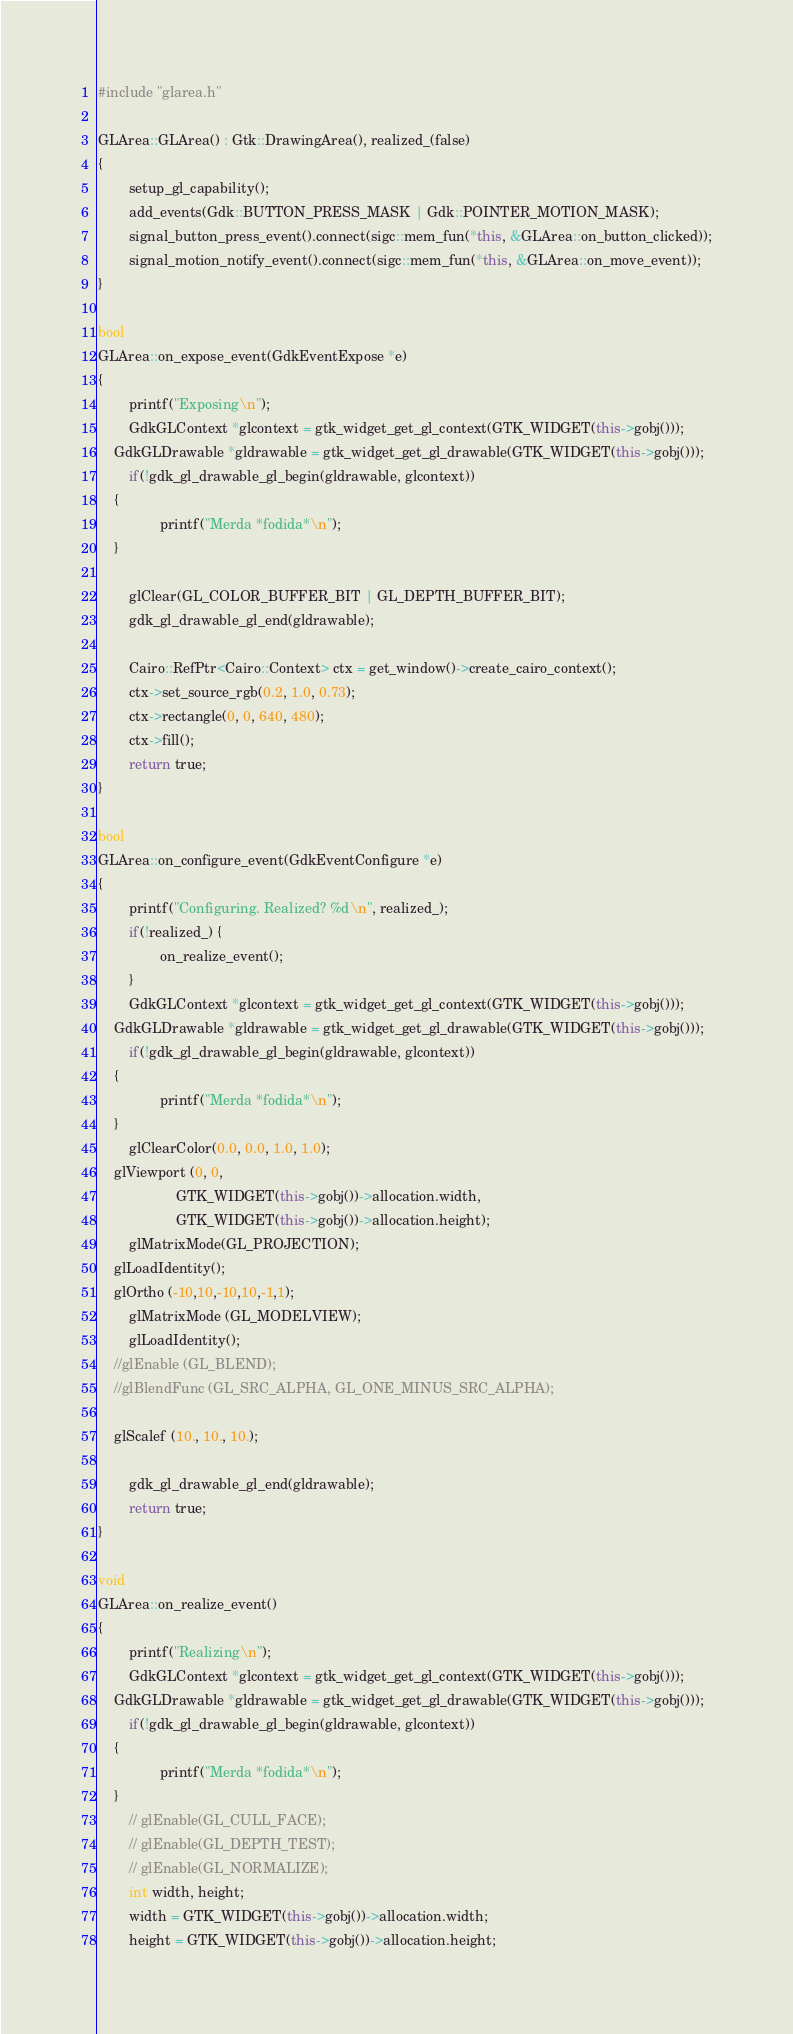Convert code to text. <code><loc_0><loc_0><loc_500><loc_500><_C++_>#include "glarea.h"

GLArea::GLArea() : Gtk::DrawingArea(), realized_(false)
{
        setup_gl_capability();
        add_events(Gdk::BUTTON_PRESS_MASK | Gdk::POINTER_MOTION_MASK);
        signal_button_press_event().connect(sigc::mem_fun(*this, &GLArea::on_button_clicked));
        signal_motion_notify_event().connect(sigc::mem_fun(*this, &GLArea::on_move_event));
}

bool
GLArea::on_expose_event(GdkEventExpose *e)
{
        printf("Exposing\n");
        GdkGLContext *glcontext = gtk_widget_get_gl_context(GTK_WIDGET(this->gobj()));
	GdkGLDrawable *gldrawable = gtk_widget_get_gl_drawable(GTK_WIDGET(this->gobj()));
        if(!gdk_gl_drawable_gl_begin(gldrawable, glcontext))
	{
                printf("Merda *fodida*\n");
	}
        
        glClear(GL_COLOR_BUFFER_BIT | GL_DEPTH_BUFFER_BIT);
        gdk_gl_drawable_gl_end(gldrawable);

        Cairo::RefPtr<Cairo::Context> ctx = get_window()->create_cairo_context();
        ctx->set_source_rgb(0.2, 1.0, 0.73);
        ctx->rectangle(0, 0, 640, 480);
        ctx->fill();
        return true;
}

bool
GLArea::on_configure_event(GdkEventConfigure *e)
{
        printf("Configuring. Realized? %d\n", realized_);
        if(!realized_) {
                on_realize_event();
        }
        GdkGLContext *glcontext = gtk_widget_get_gl_context(GTK_WIDGET(this->gobj()));
	GdkGLDrawable *gldrawable = gtk_widget_get_gl_drawable(GTK_WIDGET(this->gobj()));
        if(!gdk_gl_drawable_gl_begin(gldrawable, glcontext))
	{
                printf("Merda *fodida*\n");
	}
        glClearColor(0.0, 0.0, 1.0, 1.0);
	glViewport (0, 0,
                    GTK_WIDGET(this->gobj())->allocation.width,
                    GTK_WIDGET(this->gobj())->allocation.height);
        glMatrixMode(GL_PROJECTION);
	glLoadIdentity();
	glOrtho (-10,10,-10,10,-1,1);
        glMatrixMode (GL_MODELVIEW);
        glLoadIdentity();
	//glEnable (GL_BLEND);
	//glBlendFunc (GL_SRC_ALPHA, GL_ONE_MINUS_SRC_ALPHA);

	glScalef (10., 10., 10.);
        
        gdk_gl_drawable_gl_end(gldrawable);
        return true;
}

void
GLArea::on_realize_event()
{
        printf("Realizing\n");
        GdkGLContext *glcontext = gtk_widget_get_gl_context(GTK_WIDGET(this->gobj()));
	GdkGLDrawable *gldrawable = gtk_widget_get_gl_drawable(GTK_WIDGET(this->gobj()));
        if(!gdk_gl_drawable_gl_begin(gldrawable, glcontext))
	{
                printf("Merda *fodida*\n");
	}
        // glEnable(GL_CULL_FACE);
        // glEnable(GL_DEPTH_TEST);
        // glEnable(GL_NORMALIZE);        
        int width, height;
        width = GTK_WIDGET(this->gobj())->allocation.width;
        height = GTK_WIDGET(this->gobj())->allocation.height;</code> 